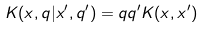<formula> <loc_0><loc_0><loc_500><loc_500>K ( x , q | x ^ { \prime } , q ^ { \prime } ) = q q ^ { \prime } K ( x , x ^ { \prime } )</formula> 